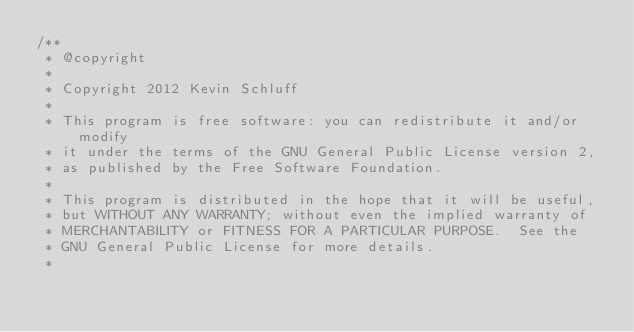Convert code to text. <code><loc_0><loc_0><loc_500><loc_500><_C++_>/**
 * @copyright
 *
 * Copyright 2012 Kevin Schluff
 *
 * This program is free software: you can redistribute it and/or modify
 * it under the terms of the GNU General Public License version 2, 
 * as published by the Free Software Foundation.
 * 
 * This program is distributed in the hope that it will be useful,
 * but WITHOUT ANY WARRANTY; without even the implied warranty of
 * MERCHANTABILITY or FITNESS FOR A PARTICULAR PURPOSE.  See the
 * GNU General Public License for more details.
 *</code> 